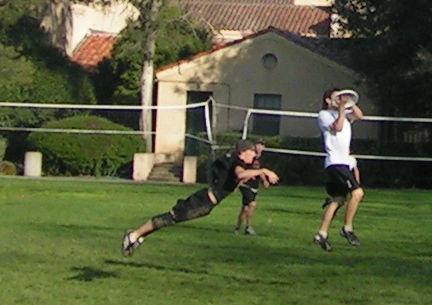What game are they playing?
Give a very brief answer. Frisbee. What type of nets are in the background of this picture?
Answer briefly. Volleyball. Why is the closest guy in that position?
Quick response, please. Falling. 